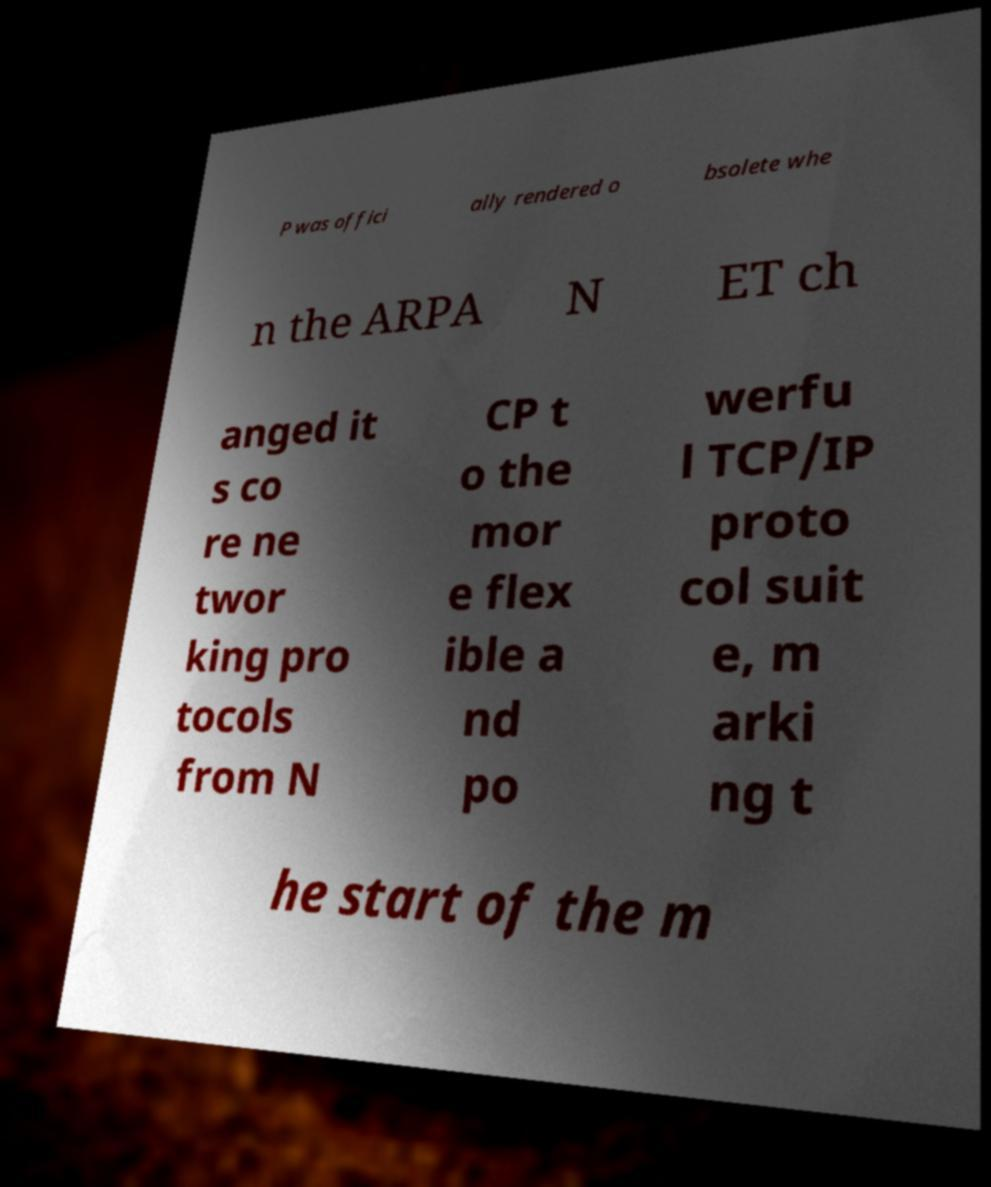Can you accurately transcribe the text from the provided image for me? P was offici ally rendered o bsolete whe n the ARPA N ET ch anged it s co re ne twor king pro tocols from N CP t o the mor e flex ible a nd po werfu l TCP/IP proto col suit e, m arki ng t he start of the m 